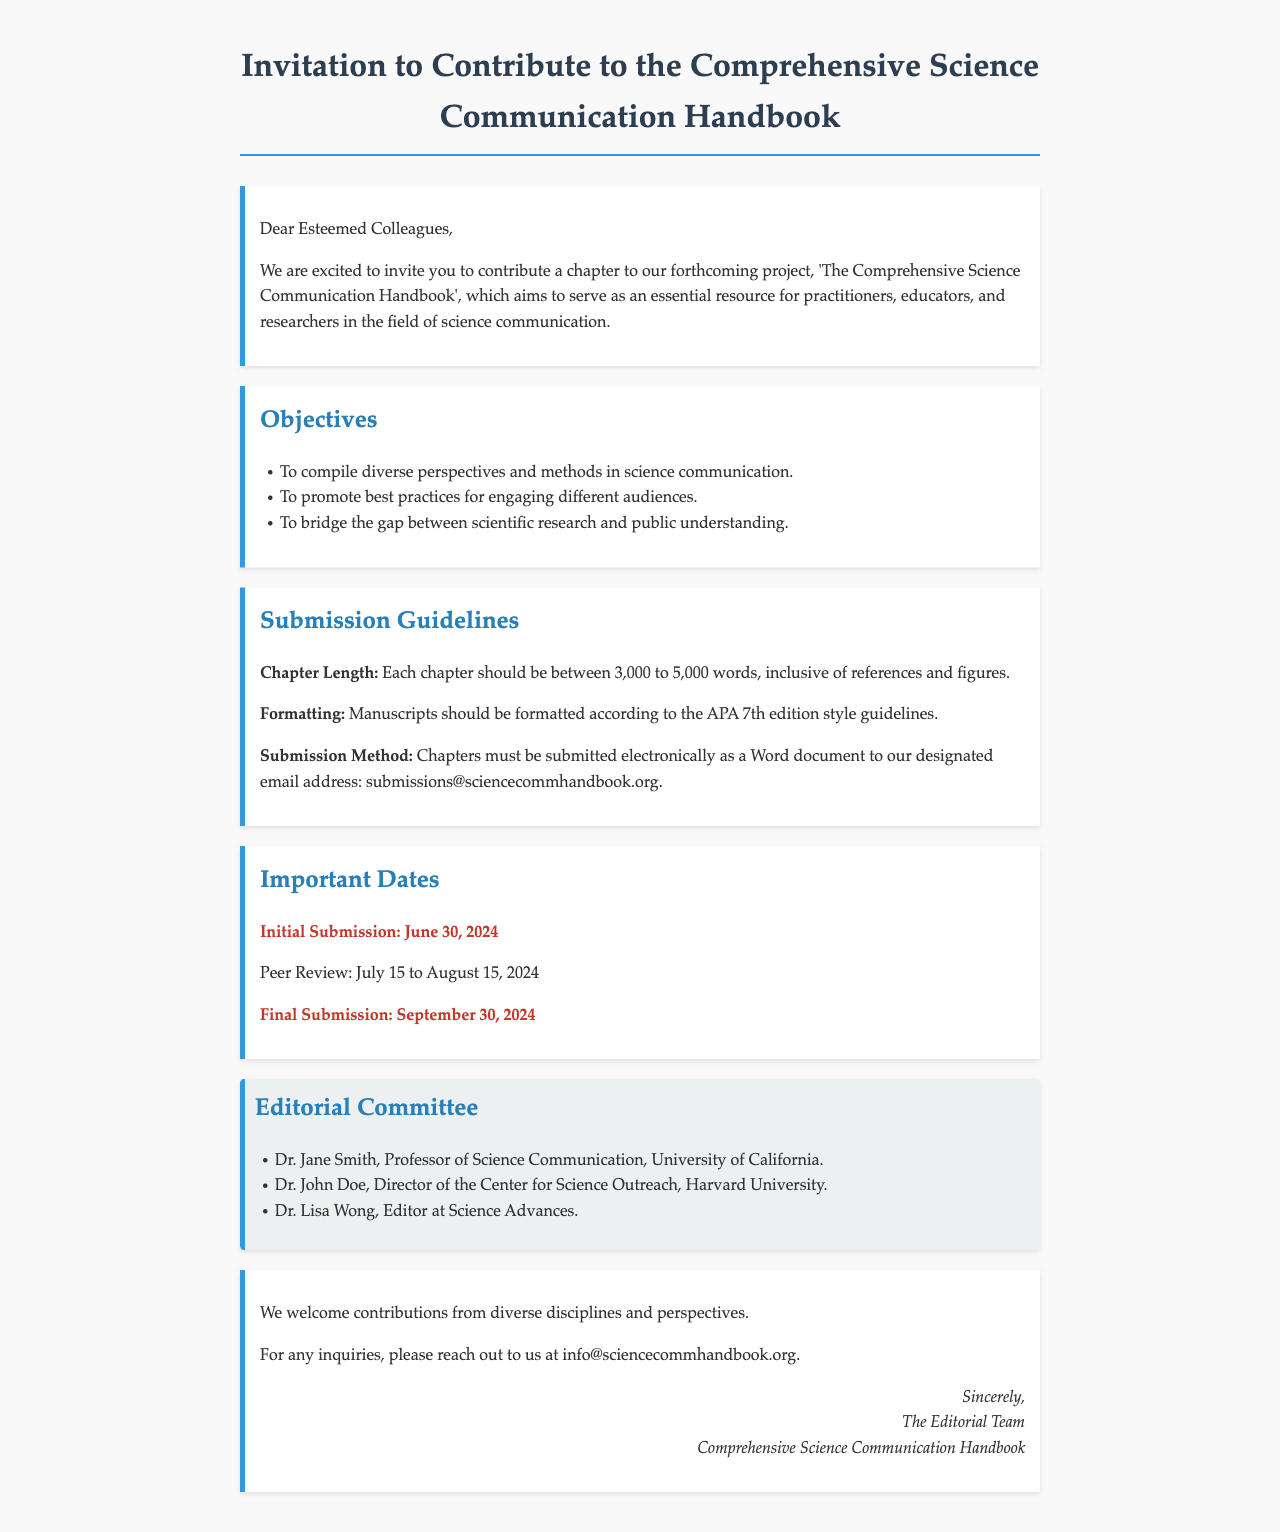What is the title of the handbook? The title of the handbook is mentioned at the beginning of the letter.
Answer: The Comprehensive Science Communication Handbook Who are the potential contributors to the handbook? The letter invites practitioners, educators, and researchers in the field of science communication to contribute.
Answer: Practitioners, educators, and researchers What is the word count range for each chapter? The specific range for the chapter length is stated in the submission guidelines.
Answer: 3,000 to 5,000 words When is the final submission deadline? The final submission date is highlighted in the important dates section of the letter.
Answer: September 30, 2024 Who is a member of the Editorial Committee? The members of the Editorial Committee are listed in their section; any name can be an answer.
Answer: Dr. Jane Smith What is the email address for chapter submissions? The designated email for submission is provided in the submission guidelines.
Answer: submissions@sciencecommhandbook.org What are the main objectives of the handbook? The objectives are outlined in a section that lists multiple points.
Answer: Compile diverse perspectives and methods in science communication During which dates will the peer review occur? The peer review period is specified in the important dates section.
Answer: July 15 to August 15, 2024 What formatting style should be used for manuscripts? The required formatting style is detailed in the submission guidelines.
Answer: APA 7th edition 